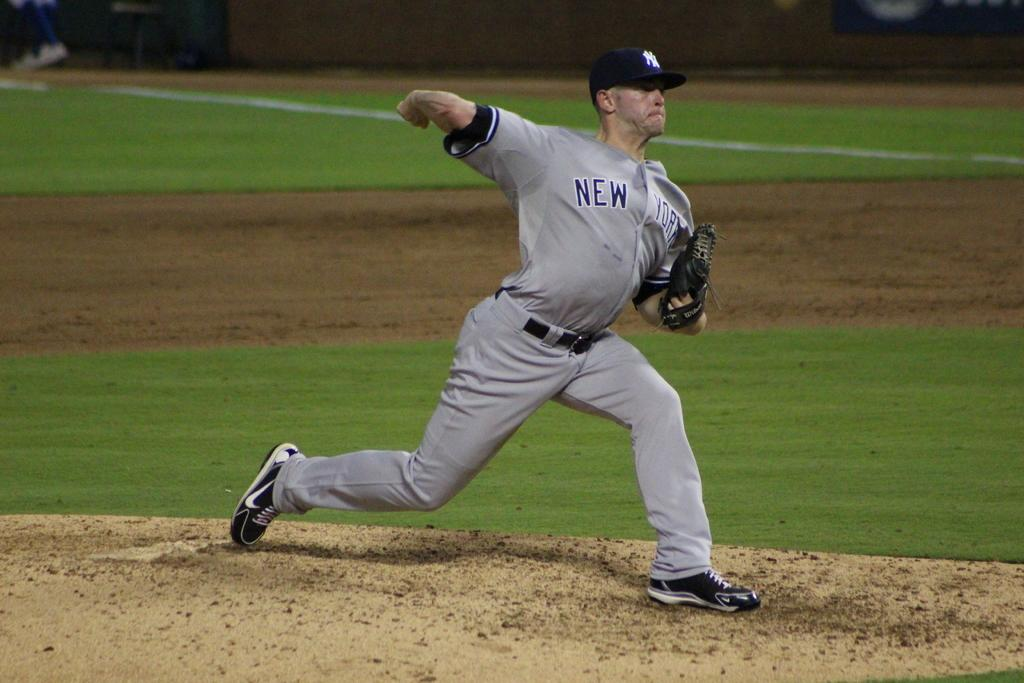<image>
Present a compact description of the photo's key features. A New York baseball team pitcher is in the bowling action. 